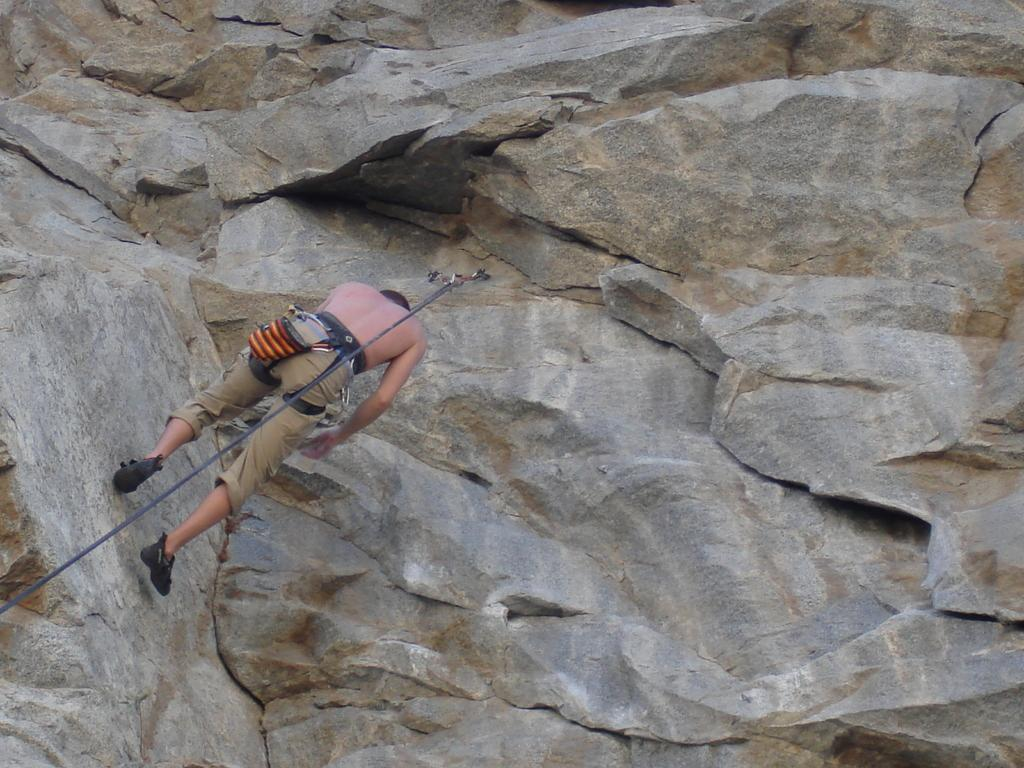Who or what is in the image? There is a person in the image. Where is the person located? The person is on a mountain. What object can be seen in the image? There is a rope in the image. Can you determine the time of day the image was taken? The image was likely taken during the day. What type of net is being used by the person in the image? There is no net visible in the image; only a person, a mountain, and a rope are present. Can you tell me how often the person in the image brushes their teeth? There is no information about the person's toothbrushing habits in the image. 